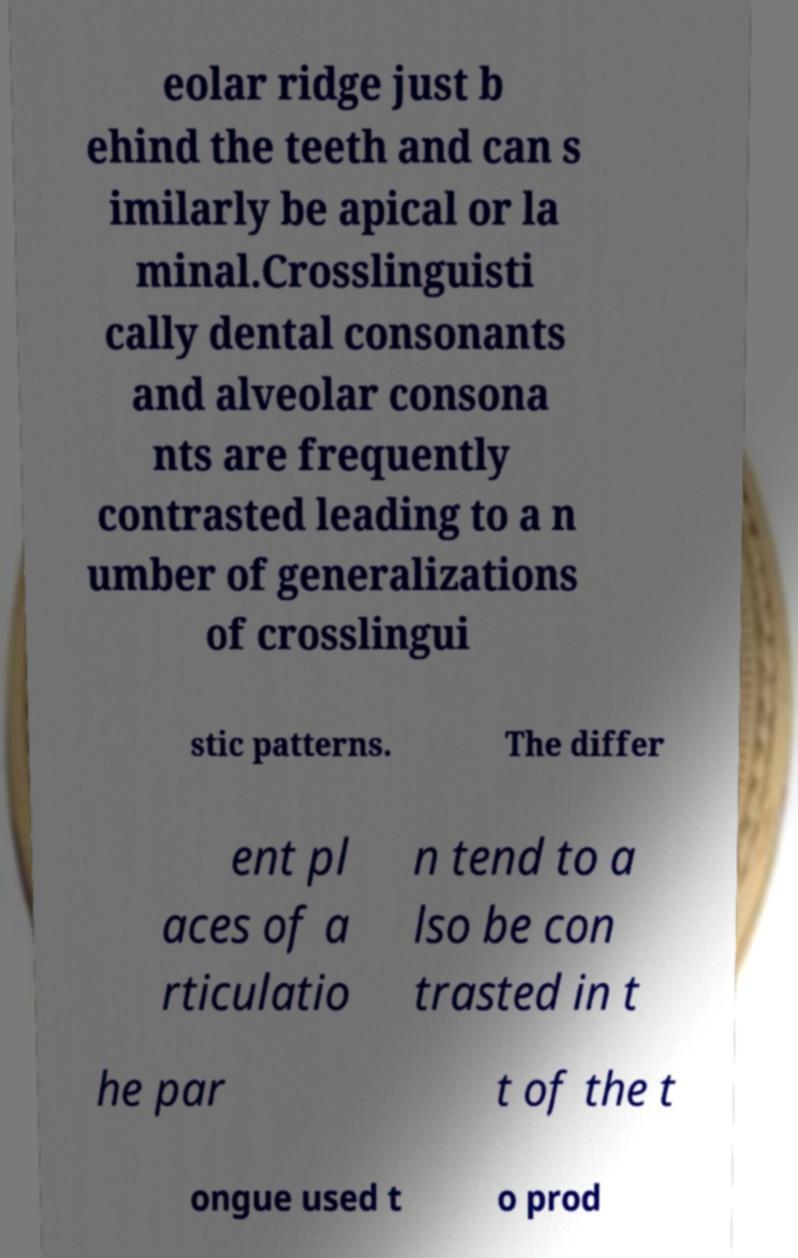Please read and relay the text visible in this image. What does it say? eolar ridge just b ehind the teeth and can s imilarly be apical or la minal.Crosslinguisti cally dental consonants and alveolar consona nts are frequently contrasted leading to a n umber of generalizations of crosslingui stic patterns. The differ ent pl aces of a rticulatio n tend to a lso be con trasted in t he par t of the t ongue used t o prod 